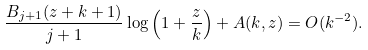<formula> <loc_0><loc_0><loc_500><loc_500>\frac { B _ { j + 1 } ( z + k + 1 ) } { j + 1 } \log \left ( 1 + \frac { z } { k } \right ) + A ( k , z ) = O ( k ^ { - 2 } ) .</formula> 